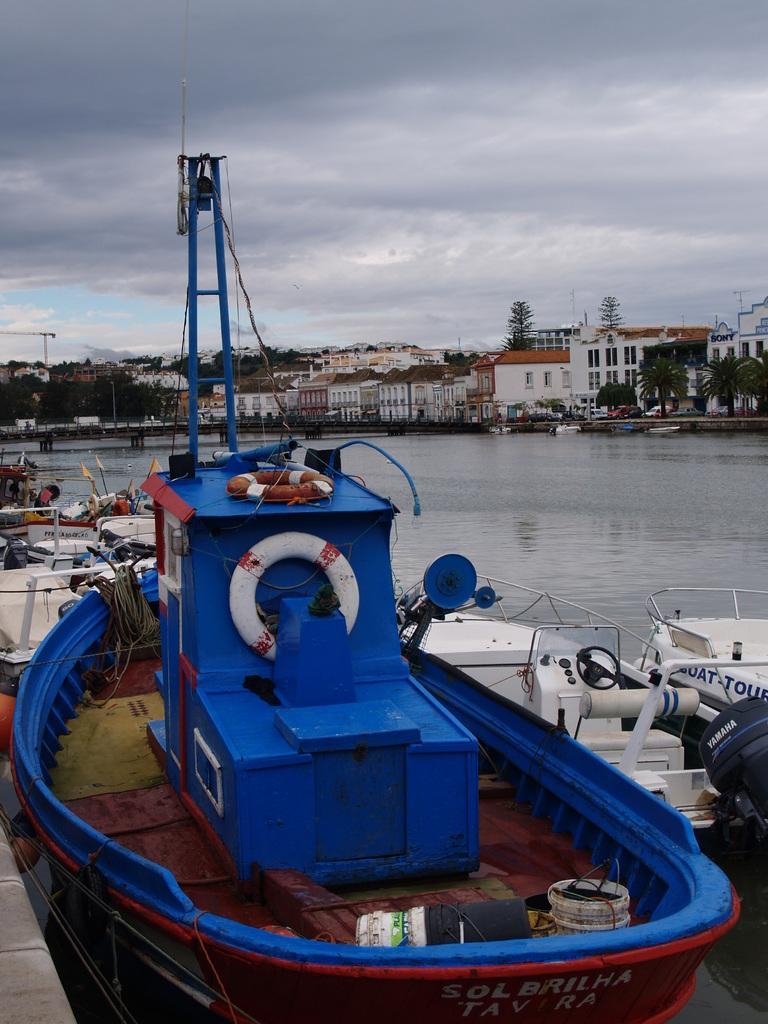How would you summarize this image in a sentence or two? We can see ships,boats and water. Background we can see buildings,trees and sky with clouds. 